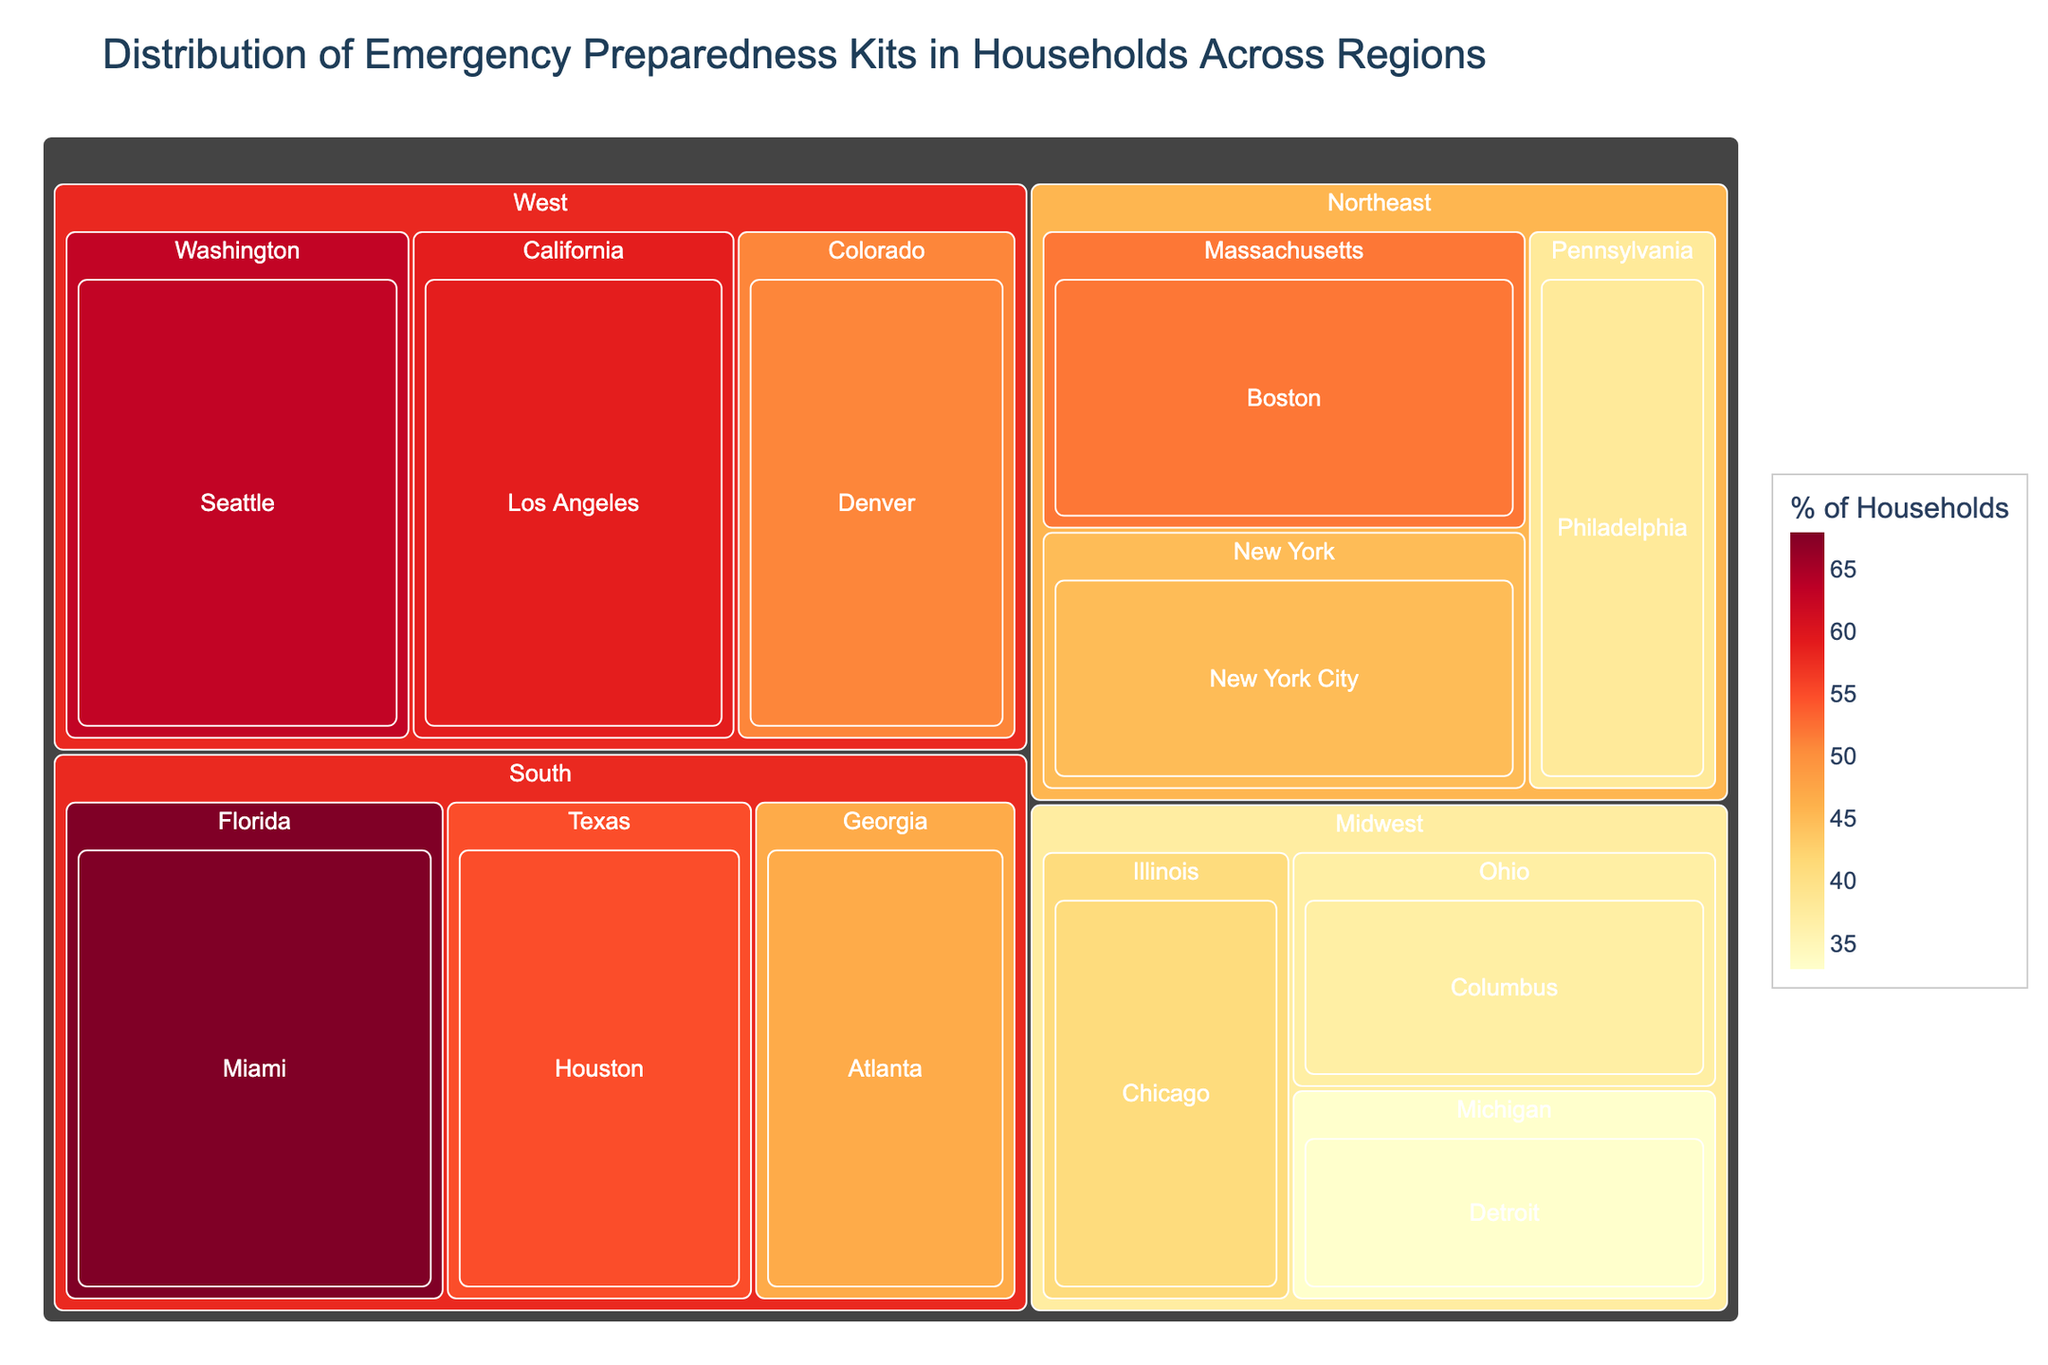Which region has the highest percentage of households with emergency kits? The figure highlights the percentage of households with emergency kits in different regions using distinct colors. The South region, particularly Miami, Florida, has the highest percentage.
Answer: South Which city in the West region has the highest percentage of households with emergency kits? Within the West region section of the treemap, compare the percentages of the cities. Seattle, Washington, has the highest percentage.
Answer: Seattle How does the percentage of households with emergency kits in Houston compare to that in New York City? Locate Houston in the South region and New York City in the Northeast region on the treemap. Houston has 55%, while New York City has 45%.
Answer: Houston has 10% more What is the combined percentage of households with emergency kits in Boston and Philadelphia? Add the percentages for Boston (52%) and Philadelphia (38%) as listed in the Northeast region. 52% + 38% = 90%
Answer: 90% Which city has the lowest percentage of households with emergency kits? Identify the smallest value within the treemap. Detroit, Michigan, with 33%, has the lowest percentage.
Answer: Detroit Rank the cities in the Midwest region by their percentage of households with emergency kits from highest to lowest. In the Midwest region, compare the percentages of Chicago (41%), Columbus (37%), and Detroit (33%). The ranking is: Chicago, Columbus, Detroit.
Answer: Chicago, Columbus, Detroit What is the percentage difference between the city with the highest and lowest percentages? Identify the highest (Miami, 68%) and lowest (Detroit, 33%) percentages, then compute the difference: 68% - 33% = 35%.
Answer: 35% Which state in the Northeast region has the most prepared households on average? Compare the average percentages of cities within each state in the Northeast region. Massachusetts (Boston 52%) and New York (NYC 45%) have only one city each, so the averages are direct. Pennsylvania (Philadelphia 38%) similarly. Boston has the highest value.
Answer: Massachusetts If you were to average the percentage of households with emergency kits in the South region, what would it be? Calculate the average by adding the values - Houston (55%), Miami (68%), and Atlanta (47%) - and dividing by the number of cities: (55% + 68% + 47%) / 3 = 170% / 3 ≈ 56.67%.
Answer: 56.67% Which region shows the most uniform distribution of households with emergency kits? Examine the variability of percentages within each region. The West region varies only between 51% and 63%, which is more uniform compared to wider variances in other regions.
Answer: West 